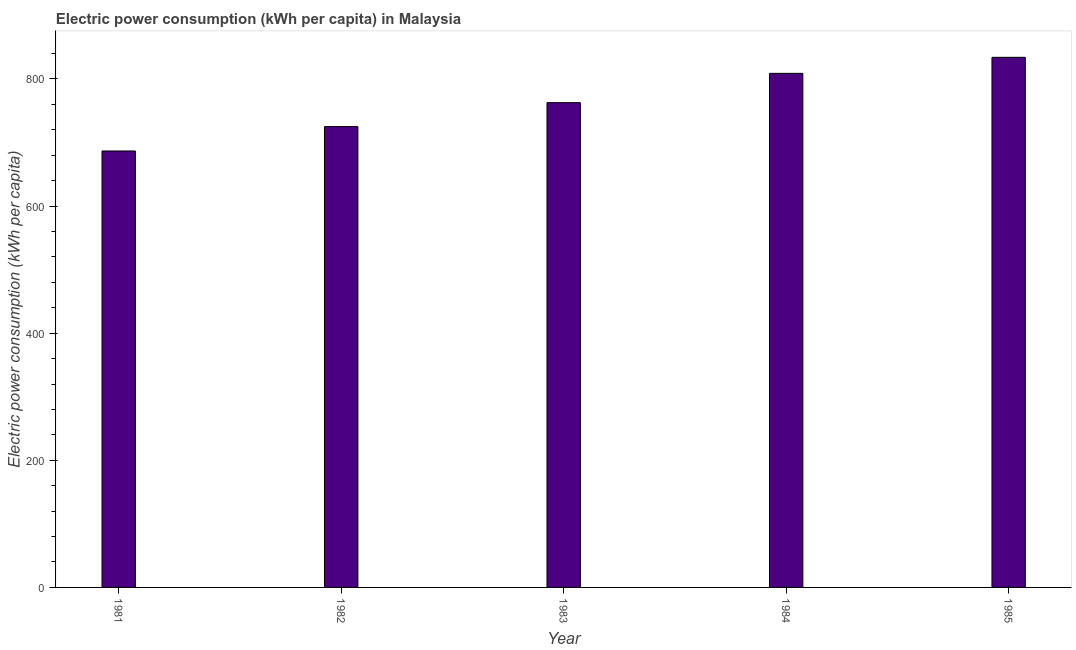Does the graph contain grids?
Keep it short and to the point. No. What is the title of the graph?
Your answer should be very brief. Electric power consumption (kWh per capita) in Malaysia. What is the label or title of the Y-axis?
Make the answer very short. Electric power consumption (kWh per capita). What is the electric power consumption in 1981?
Your response must be concise. 686.6. Across all years, what is the maximum electric power consumption?
Keep it short and to the point. 833.91. Across all years, what is the minimum electric power consumption?
Offer a very short reply. 686.6. In which year was the electric power consumption maximum?
Your answer should be very brief. 1985. In which year was the electric power consumption minimum?
Keep it short and to the point. 1981. What is the sum of the electric power consumption?
Keep it short and to the point. 3816.84. What is the difference between the electric power consumption in 1981 and 1985?
Your answer should be compact. -147.31. What is the average electric power consumption per year?
Provide a short and direct response. 763.37. What is the median electric power consumption?
Offer a terse response. 762.65. What is the ratio of the electric power consumption in 1983 to that in 1985?
Your answer should be very brief. 0.92. What is the difference between the highest and the second highest electric power consumption?
Your answer should be very brief. 25.21. What is the difference between the highest and the lowest electric power consumption?
Give a very brief answer. 147.31. In how many years, is the electric power consumption greater than the average electric power consumption taken over all years?
Ensure brevity in your answer.  2. How many years are there in the graph?
Your answer should be compact. 5. What is the difference between two consecutive major ticks on the Y-axis?
Provide a short and direct response. 200. What is the Electric power consumption (kWh per capita) of 1981?
Give a very brief answer. 686.6. What is the Electric power consumption (kWh per capita) of 1982?
Provide a succinct answer. 724.99. What is the Electric power consumption (kWh per capita) in 1983?
Offer a very short reply. 762.65. What is the Electric power consumption (kWh per capita) in 1984?
Offer a terse response. 808.69. What is the Electric power consumption (kWh per capita) in 1985?
Your answer should be very brief. 833.91. What is the difference between the Electric power consumption (kWh per capita) in 1981 and 1982?
Ensure brevity in your answer.  -38.4. What is the difference between the Electric power consumption (kWh per capita) in 1981 and 1983?
Your answer should be very brief. -76.05. What is the difference between the Electric power consumption (kWh per capita) in 1981 and 1984?
Offer a terse response. -122.1. What is the difference between the Electric power consumption (kWh per capita) in 1981 and 1985?
Make the answer very short. -147.31. What is the difference between the Electric power consumption (kWh per capita) in 1982 and 1983?
Make the answer very short. -37.65. What is the difference between the Electric power consumption (kWh per capita) in 1982 and 1984?
Your answer should be compact. -83.7. What is the difference between the Electric power consumption (kWh per capita) in 1982 and 1985?
Your answer should be very brief. -108.91. What is the difference between the Electric power consumption (kWh per capita) in 1983 and 1984?
Keep it short and to the point. -46.05. What is the difference between the Electric power consumption (kWh per capita) in 1983 and 1985?
Keep it short and to the point. -71.26. What is the difference between the Electric power consumption (kWh per capita) in 1984 and 1985?
Provide a short and direct response. -25.21. What is the ratio of the Electric power consumption (kWh per capita) in 1981 to that in 1982?
Provide a short and direct response. 0.95. What is the ratio of the Electric power consumption (kWh per capita) in 1981 to that in 1983?
Your answer should be compact. 0.9. What is the ratio of the Electric power consumption (kWh per capita) in 1981 to that in 1984?
Ensure brevity in your answer.  0.85. What is the ratio of the Electric power consumption (kWh per capita) in 1981 to that in 1985?
Make the answer very short. 0.82. What is the ratio of the Electric power consumption (kWh per capita) in 1982 to that in 1983?
Offer a terse response. 0.95. What is the ratio of the Electric power consumption (kWh per capita) in 1982 to that in 1984?
Keep it short and to the point. 0.9. What is the ratio of the Electric power consumption (kWh per capita) in 1982 to that in 1985?
Your answer should be very brief. 0.87. What is the ratio of the Electric power consumption (kWh per capita) in 1983 to that in 1984?
Ensure brevity in your answer.  0.94. What is the ratio of the Electric power consumption (kWh per capita) in 1983 to that in 1985?
Your answer should be very brief. 0.92. What is the ratio of the Electric power consumption (kWh per capita) in 1984 to that in 1985?
Your answer should be very brief. 0.97. 